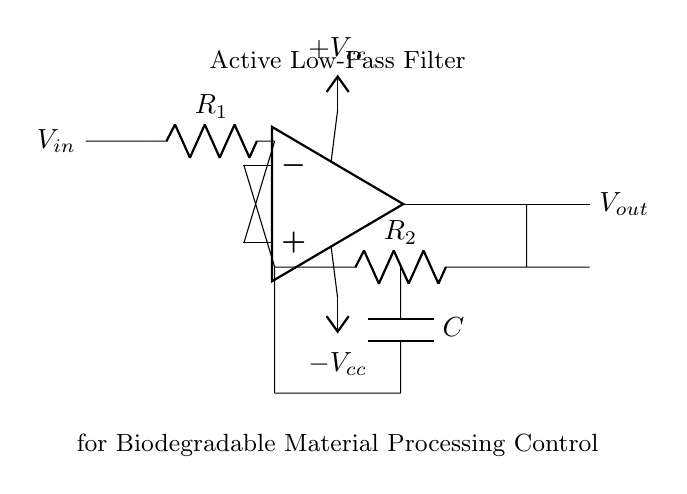What type of filter is this circuit? The circuit is labeled as an "Active Low-Pass Filter," which indicates that it allows low-frequency signals to pass while attenuating high-frequency signals.
Answer: Active Low-Pass Filter What are the values of the resistors used? The circuit shows two resistors: R1 and R2. However, specific numerical values are not provided, just labels.
Answer: R1, R2 What is the purpose of the capacitor in this circuit? The capacitor is in the feedback loop and is used to set the cutoff frequency, thus affecting the filter's behavior regarding which frequencies are allowed to pass.
Answer: Set cutoff frequency What is the significance of the power supply voltages? The circuit has two power supply connections, labeled as positive and negative voltages (Vcc). They provide the necessary power for the operational amplifier to function.
Answer: Power for op-amp Where is the input voltage applied in the circuit? The input voltage (Vin) is applied to the non-inverting terminal of the operational amplifier, as indicated by the connection to the point just before R1.
Answer: Non-inverting terminal How does this active filter differ from a passive filter? Active filters use amplifying components like operational amplifiers, allowing for gain and improved performance at various frequencies, unlike passive filters that only use passive components.
Answer: Uses amplifiers What is being controlled by this active filter in the context of biodegradable materials? The circuit is labeled for "Biodegradable Material Processing Control," indicating that it regulates the processing equipment's functioning based on the filtered signals.
Answer: Processing equipment 